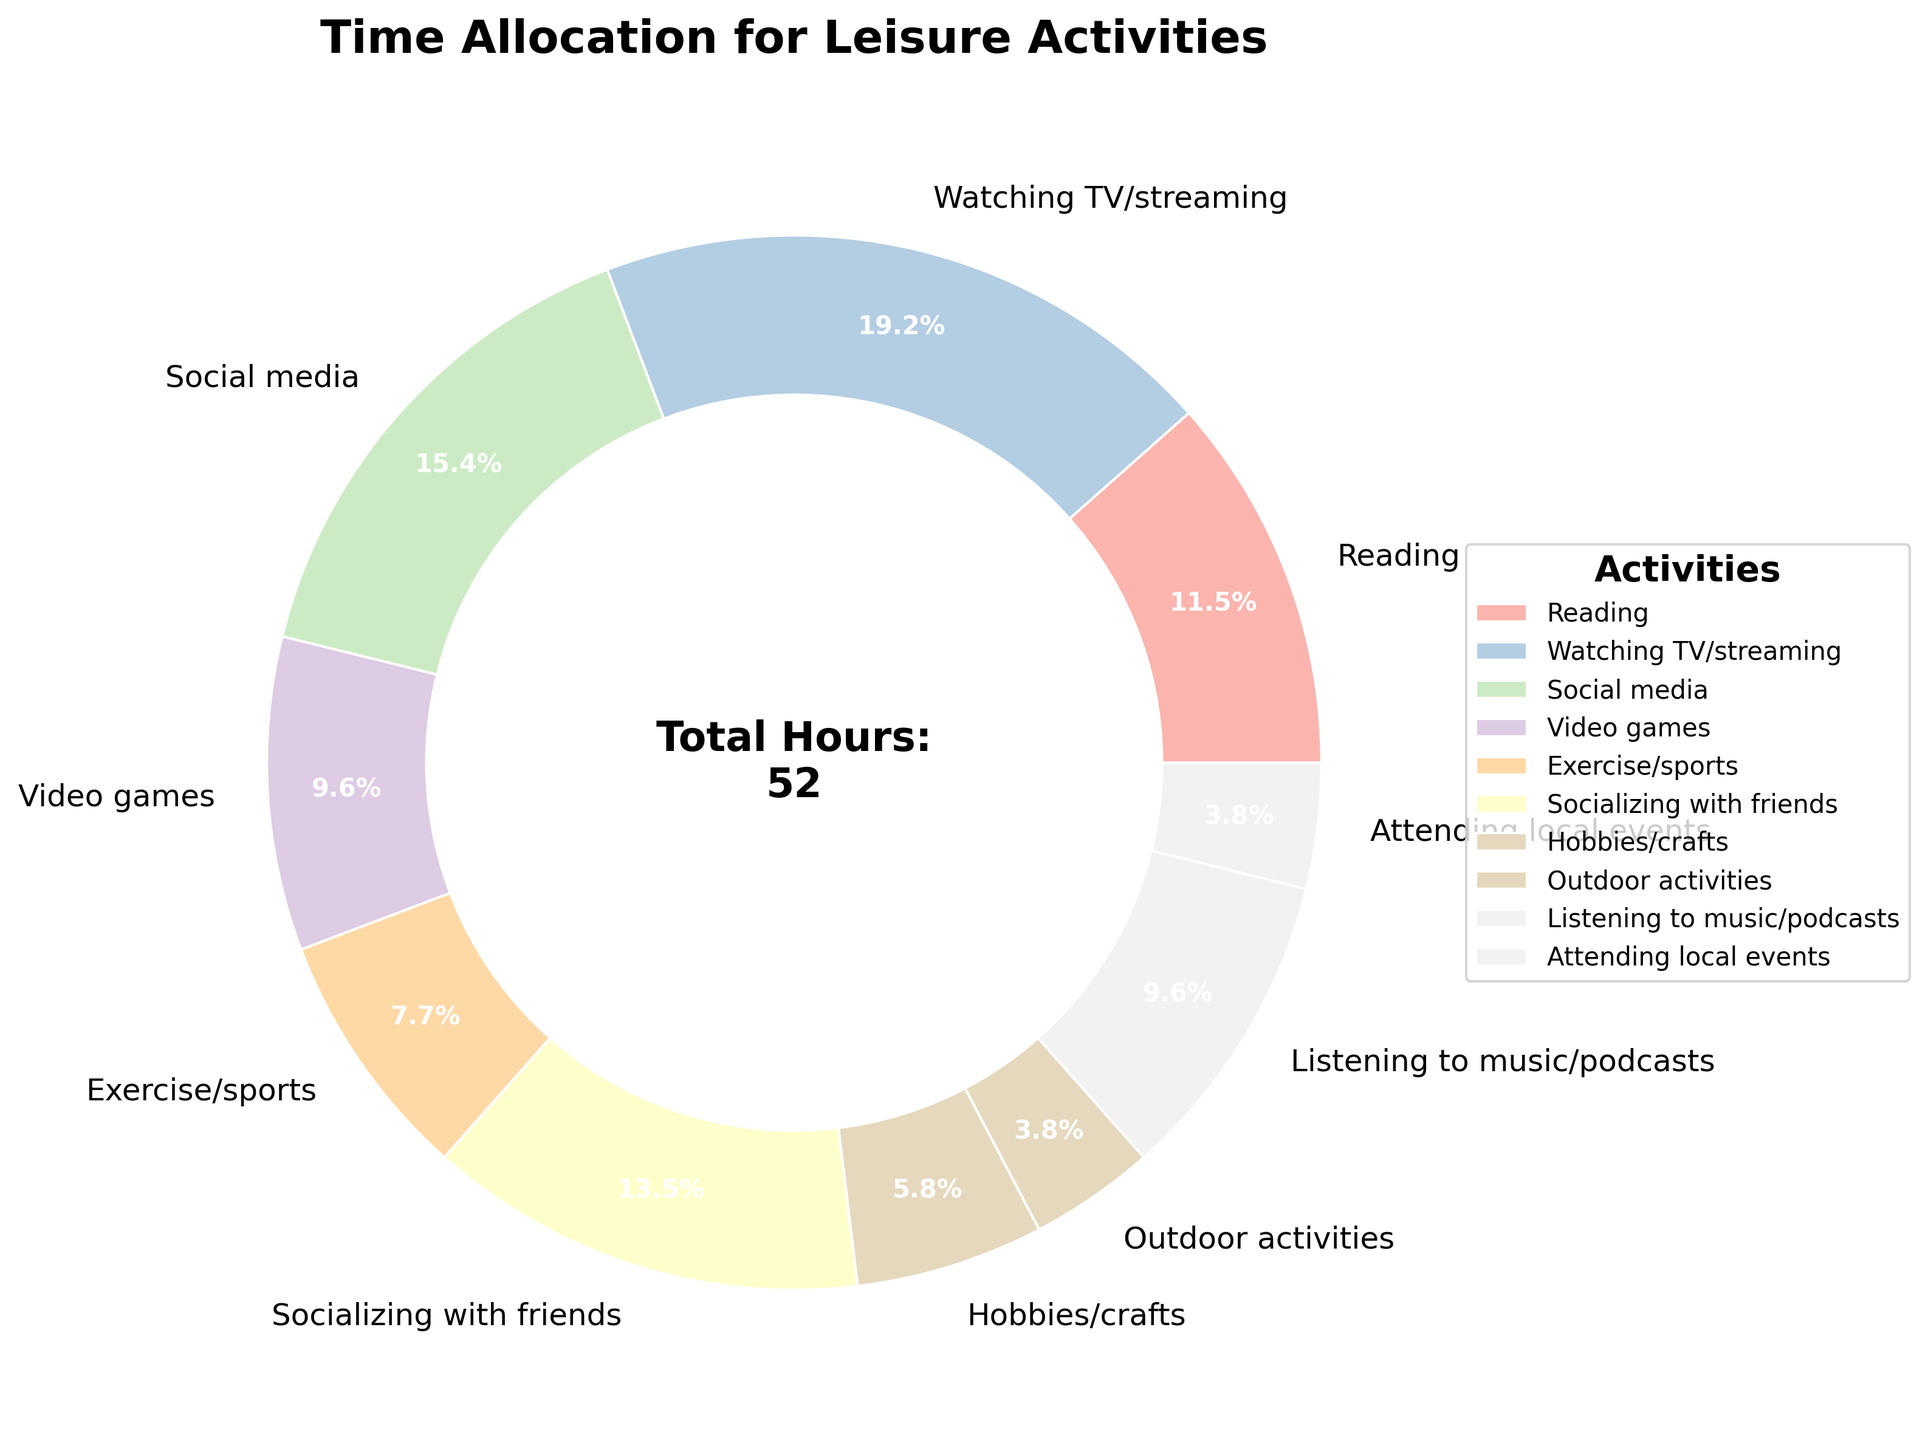How much more time is allocated to Watching TV/streaming compared to Exercise/sports? Watching TV/streaming is allocated 10 hours per week, and Exercise/sports is allocated 4 hours per week. The difference is 10 - 4.
Answer: 6 hours What percentage of time is spent on Socializing with friends? The total hours per week for all activities is 52. Socializing with friends takes up 7 hours per week, so the percentage is (7/52) * 100%.
Answer: 13.5% Which activity has the least amount of time allocated? The pie chart shows various activities, and the one with the smallest wedge represents the least time allocation. Outdoor activities and Attending local events each have the same smallest wedge.
Answer: Outdoor activities and Attending local events How much combined time is spent on Social media and Listening to music/podcasts? Social media is 8 hours per week, and Listening to music/podcasts is 5 hours per week. Combined time is 8 + 5.
Answer: 13 hours Which takes up more time: Video games or Hobbies/crafts? The pie chart shows that Video games take up 5 hours per week while Hobbies/crafts take up 3 hours per week.
Answer: Video games How does the time spent on Reading compare to the time spent on Exercise/sports? Reading is allocated 6 hours per week and Exercise/sports is allocated 4 hours per week. Reading is more.
Answer: Reading If the time spent on Watching TV/streaming was doubled, what would be the new total hours for Watching TV/streaming? Currently, Watching TV/streaming is 10 hours per week. Doubling this amount is 10 * 2.
Answer: 20 hours What percentage of time is spent on Video games and Hobbies/crafts combined? Video games and Hobbies/crafts allocate 5 and 3 hours per week, respectively. Combined they are 8 hours. Percentage is (8/52) * 100%.
Answer: 15.4% What is the total time spent on activities labeled as Exercise/Sports, Outdoor activities, and Attending local events combined? Exercise/sports is 4 hours, Outdoor activities is 2 hours, and Attending local events is 2 hours. Combined is 4 + 2 + 2.
Answer: 8 hours 